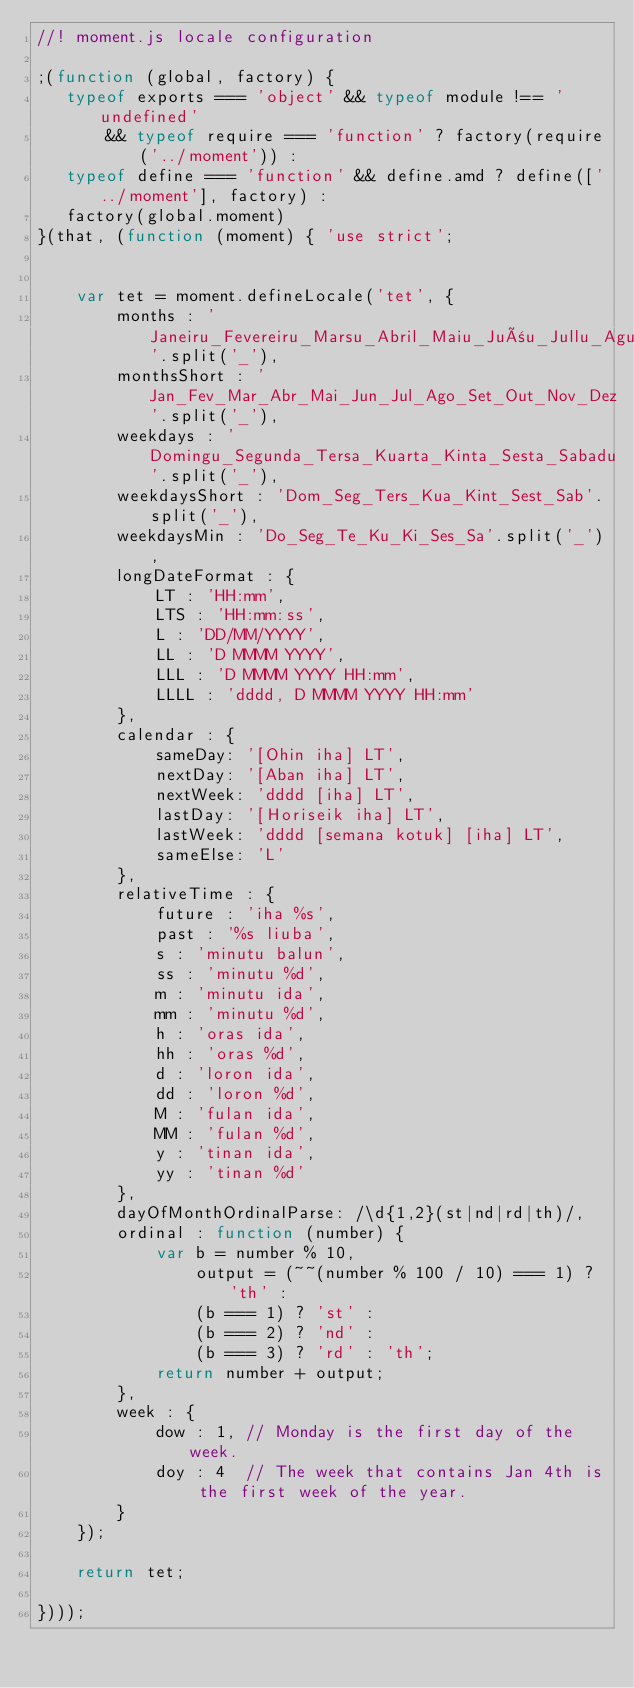Convert code to text. <code><loc_0><loc_0><loc_500><loc_500><_JavaScript_>//! moment.js locale configuration

;(function (global, factory) {
   typeof exports === 'object' && typeof module !== 'undefined'
       && typeof require === 'function' ? factory(require('../moment')) :
   typeof define === 'function' && define.amd ? define(['../moment'], factory) :
   factory(global.moment)
}(that, (function (moment) { 'use strict';


    var tet = moment.defineLocale('tet', {
        months : 'Janeiru_Fevereiru_Marsu_Abril_Maiu_Juñu_Jullu_Agustu_Setembru_Outubru_Novembru_Dezembru'.split('_'),
        monthsShort : 'Jan_Fev_Mar_Abr_Mai_Jun_Jul_Ago_Set_Out_Nov_Dez'.split('_'),
        weekdays : 'Domingu_Segunda_Tersa_Kuarta_Kinta_Sesta_Sabadu'.split('_'),
        weekdaysShort : 'Dom_Seg_Ters_Kua_Kint_Sest_Sab'.split('_'),
        weekdaysMin : 'Do_Seg_Te_Ku_Ki_Ses_Sa'.split('_'),
        longDateFormat : {
            LT : 'HH:mm',
            LTS : 'HH:mm:ss',
            L : 'DD/MM/YYYY',
            LL : 'D MMMM YYYY',
            LLL : 'D MMMM YYYY HH:mm',
            LLLL : 'dddd, D MMMM YYYY HH:mm'
        },
        calendar : {
            sameDay: '[Ohin iha] LT',
            nextDay: '[Aban iha] LT',
            nextWeek: 'dddd [iha] LT',
            lastDay: '[Horiseik iha] LT',
            lastWeek: 'dddd [semana kotuk] [iha] LT',
            sameElse: 'L'
        },
        relativeTime : {
            future : 'iha %s',
            past : '%s liuba',
            s : 'minutu balun',
            ss : 'minutu %d',
            m : 'minutu ida',
            mm : 'minutu %d',
            h : 'oras ida',
            hh : 'oras %d',
            d : 'loron ida',
            dd : 'loron %d',
            M : 'fulan ida',
            MM : 'fulan %d',
            y : 'tinan ida',
            yy : 'tinan %d'
        },
        dayOfMonthOrdinalParse: /\d{1,2}(st|nd|rd|th)/,
        ordinal : function (number) {
            var b = number % 10,
                output = (~~(number % 100 / 10) === 1) ? 'th' :
                (b === 1) ? 'st' :
                (b === 2) ? 'nd' :
                (b === 3) ? 'rd' : 'th';
            return number + output;
        },
        week : {
            dow : 1, // Monday is the first day of the week.
            doy : 4  // The week that contains Jan 4th is the first week of the year.
        }
    });

    return tet;

})));
</code> 